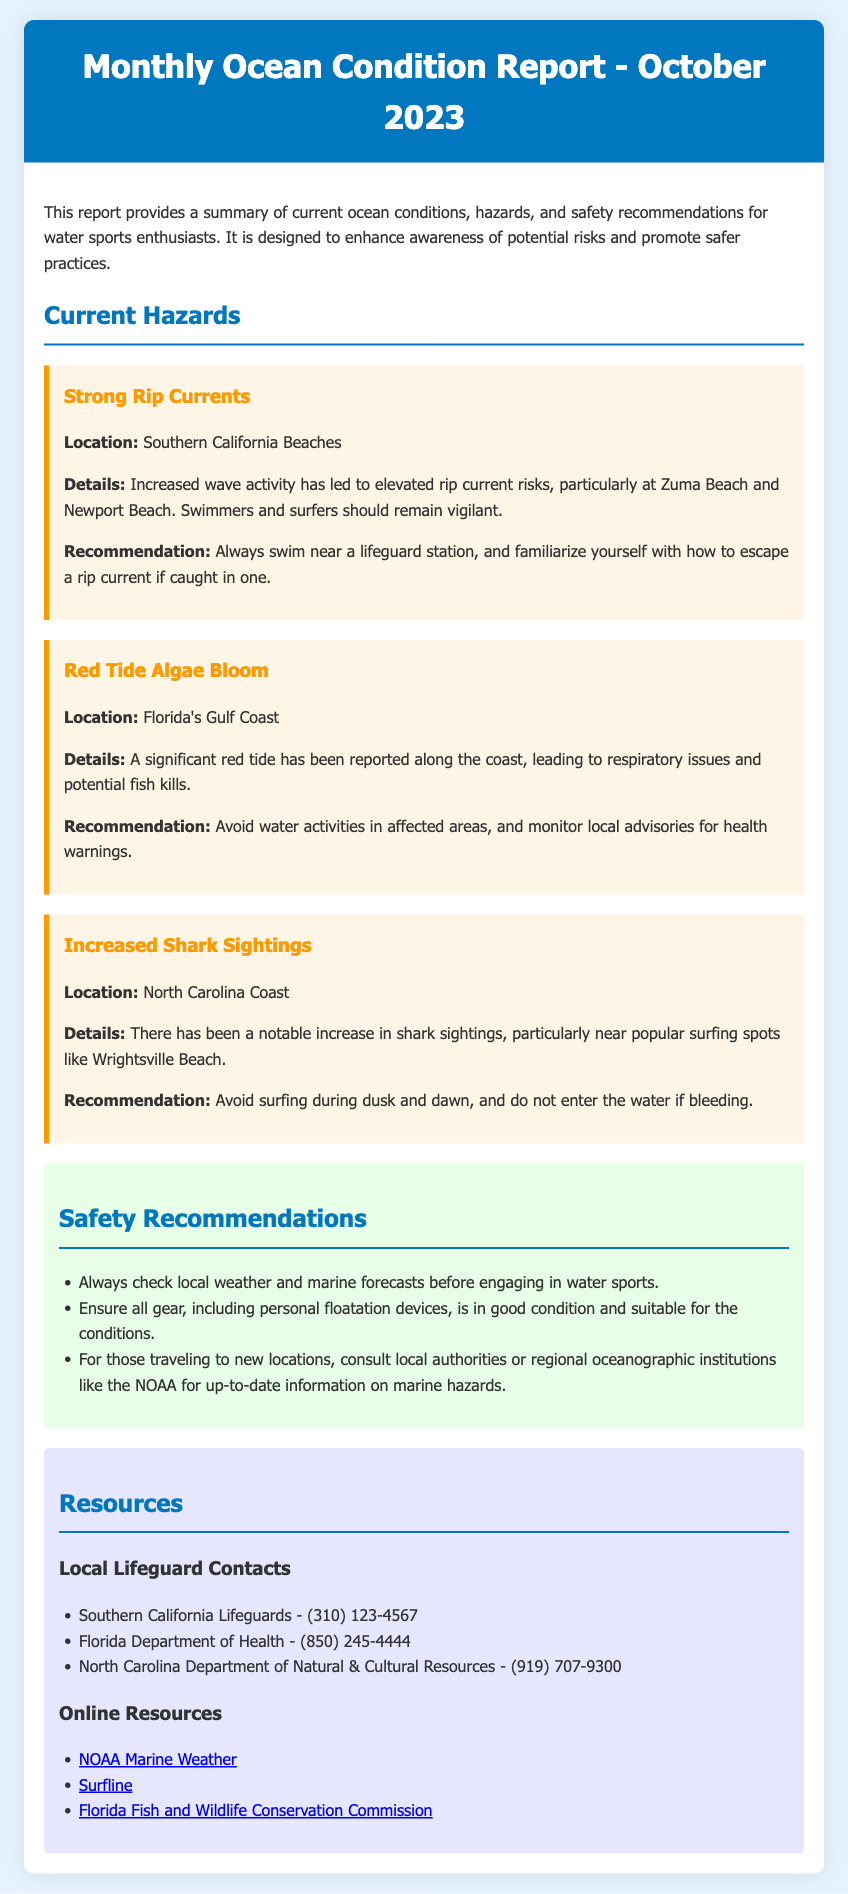What is the title of the report? The title of the report is found in the header section and indicates the month and year of the report.
Answer: Monthly Ocean Condition Report - October 2023 What is one of the reported hazards? The document lists specific hazards, including rip currents, red tide, and shark sightings.
Answer: Strong Rip Currents Where are the strong rip currents located? The hazard section provides a specific location associated with the reported hazard.
Answer: Southern California Beaches What should swimmers do if caught in a rip current? The recommendation section provides guidance on safety measures to take in specific situations.
Answer: Familiarize yourself with how to escape a rip current What is a recommendation related to gear? The safety recommendations provide guidance on personal equipment and practices for safety.
Answer: Ensure all gear, including personal floatation devices, is in good condition How many shark sightings have been reported? The document does not provide a number but mentions an increase in sightings.
Answer: Increased What is a recommended action regarding red tide? The document gives specific recommendations regarding health and safety in relation to environmental hazards.
Answer: Avoid water activities in affected areas Which department can be contacted for Florida health advisories? The resources section includes contact information for local health departments, specifying whom to reach for health related queries.
Answer: Florida Department of Health Name one online resource for marine weather. The online resources section lists websites that provide relevant information, including one for marine weather.
Answer: NOAA Marine Weather 